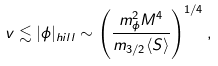Convert formula to latex. <formula><loc_0><loc_0><loc_500><loc_500>v \lesssim | \phi | _ { h i l l } \sim \left ( \frac { m _ { \phi } ^ { 2 } M ^ { 4 } } { m _ { 3 / 2 } \langle S \rangle } \right ) ^ { 1 / 4 } ,</formula> 